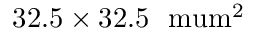Convert formula to latex. <formula><loc_0><loc_0><loc_500><loc_500>3 2 . 5 \times 3 2 . 5 { \ m u m } ^ { 2 }</formula> 